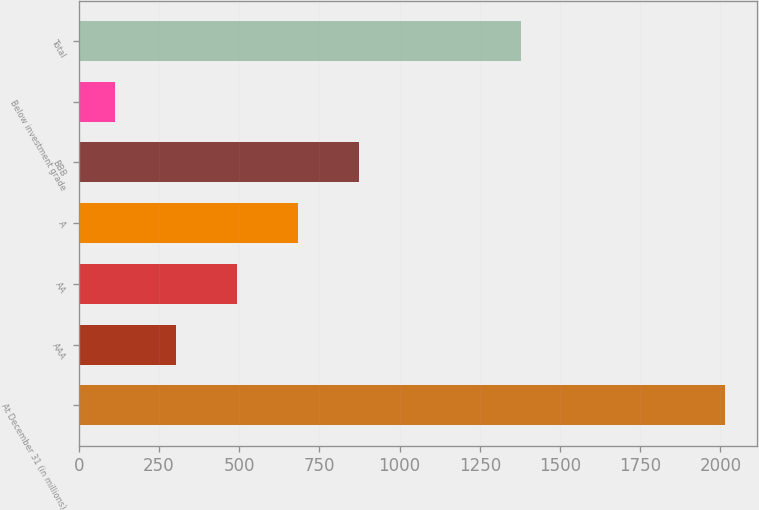Convert chart to OTSL. <chart><loc_0><loc_0><loc_500><loc_500><bar_chart><fcel>At December 31 (in millions)<fcel>AAA<fcel>AA<fcel>A<fcel>BBB<fcel>Below investment grade<fcel>Total<nl><fcel>2013<fcel>303.9<fcel>493.8<fcel>683.7<fcel>873.6<fcel>114<fcel>1377<nl></chart> 